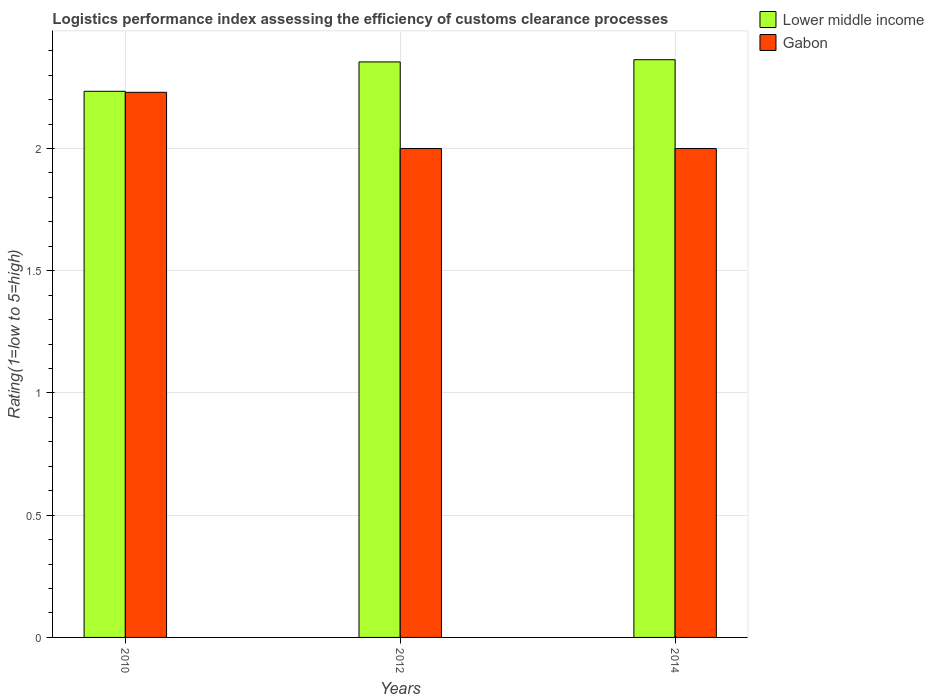How many different coloured bars are there?
Your response must be concise. 2. Are the number of bars per tick equal to the number of legend labels?
Offer a terse response. Yes. What is the Logistic performance index in Lower middle income in 2012?
Your answer should be compact. 2.35. Across all years, what is the maximum Logistic performance index in Gabon?
Ensure brevity in your answer.  2.23. Across all years, what is the minimum Logistic performance index in Lower middle income?
Your answer should be compact. 2.23. What is the total Logistic performance index in Gabon in the graph?
Provide a succinct answer. 6.23. What is the difference between the Logistic performance index in Gabon in 2010 and that in 2012?
Make the answer very short. 0.23. What is the difference between the Logistic performance index in Gabon in 2014 and the Logistic performance index in Lower middle income in 2012?
Your answer should be very brief. -0.35. What is the average Logistic performance index in Gabon per year?
Keep it short and to the point. 2.08. In the year 2014, what is the difference between the Logistic performance index in Gabon and Logistic performance index in Lower middle income?
Provide a short and direct response. -0.36. In how many years, is the Logistic performance index in Lower middle income greater than 0.8?
Offer a terse response. 3. What is the ratio of the Logistic performance index in Lower middle income in 2010 to that in 2012?
Provide a short and direct response. 0.95. Is the Logistic performance index in Lower middle income in 2010 less than that in 2012?
Offer a very short reply. Yes. Is the difference between the Logistic performance index in Gabon in 2010 and 2014 greater than the difference between the Logistic performance index in Lower middle income in 2010 and 2014?
Offer a very short reply. Yes. What is the difference between the highest and the second highest Logistic performance index in Lower middle income?
Ensure brevity in your answer.  0.01. What is the difference between the highest and the lowest Logistic performance index in Lower middle income?
Your response must be concise. 0.13. What does the 1st bar from the left in 2014 represents?
Keep it short and to the point. Lower middle income. What does the 2nd bar from the right in 2014 represents?
Provide a succinct answer. Lower middle income. Are all the bars in the graph horizontal?
Provide a succinct answer. No. How many years are there in the graph?
Your response must be concise. 3. Does the graph contain any zero values?
Offer a very short reply. No. Does the graph contain grids?
Provide a short and direct response. Yes. What is the title of the graph?
Make the answer very short. Logistics performance index assessing the efficiency of customs clearance processes. What is the label or title of the Y-axis?
Give a very brief answer. Rating(1=low to 5=high). What is the Rating(1=low to 5=high) in Lower middle income in 2010?
Your answer should be compact. 2.23. What is the Rating(1=low to 5=high) of Gabon in 2010?
Offer a very short reply. 2.23. What is the Rating(1=low to 5=high) in Lower middle income in 2012?
Give a very brief answer. 2.35. What is the Rating(1=low to 5=high) in Lower middle income in 2014?
Provide a short and direct response. 2.36. What is the Rating(1=low to 5=high) in Gabon in 2014?
Your response must be concise. 2. Across all years, what is the maximum Rating(1=low to 5=high) in Lower middle income?
Keep it short and to the point. 2.36. Across all years, what is the maximum Rating(1=low to 5=high) in Gabon?
Keep it short and to the point. 2.23. Across all years, what is the minimum Rating(1=low to 5=high) in Lower middle income?
Keep it short and to the point. 2.23. What is the total Rating(1=low to 5=high) in Lower middle income in the graph?
Provide a short and direct response. 6.95. What is the total Rating(1=low to 5=high) in Gabon in the graph?
Offer a very short reply. 6.23. What is the difference between the Rating(1=low to 5=high) of Lower middle income in 2010 and that in 2012?
Make the answer very short. -0.12. What is the difference between the Rating(1=low to 5=high) in Gabon in 2010 and that in 2012?
Your response must be concise. 0.23. What is the difference between the Rating(1=low to 5=high) in Lower middle income in 2010 and that in 2014?
Your answer should be very brief. -0.13. What is the difference between the Rating(1=low to 5=high) of Gabon in 2010 and that in 2014?
Give a very brief answer. 0.23. What is the difference between the Rating(1=low to 5=high) of Lower middle income in 2012 and that in 2014?
Provide a succinct answer. -0.01. What is the difference between the Rating(1=low to 5=high) in Lower middle income in 2010 and the Rating(1=low to 5=high) in Gabon in 2012?
Provide a succinct answer. 0.23. What is the difference between the Rating(1=low to 5=high) in Lower middle income in 2010 and the Rating(1=low to 5=high) in Gabon in 2014?
Your answer should be compact. 0.23. What is the difference between the Rating(1=low to 5=high) of Lower middle income in 2012 and the Rating(1=low to 5=high) of Gabon in 2014?
Your answer should be compact. 0.35. What is the average Rating(1=low to 5=high) of Lower middle income per year?
Offer a terse response. 2.32. What is the average Rating(1=low to 5=high) in Gabon per year?
Your response must be concise. 2.08. In the year 2010, what is the difference between the Rating(1=low to 5=high) in Lower middle income and Rating(1=low to 5=high) in Gabon?
Your response must be concise. 0. In the year 2012, what is the difference between the Rating(1=low to 5=high) of Lower middle income and Rating(1=low to 5=high) of Gabon?
Your response must be concise. 0.35. In the year 2014, what is the difference between the Rating(1=low to 5=high) in Lower middle income and Rating(1=low to 5=high) in Gabon?
Offer a very short reply. 0.36. What is the ratio of the Rating(1=low to 5=high) in Lower middle income in 2010 to that in 2012?
Offer a very short reply. 0.95. What is the ratio of the Rating(1=low to 5=high) in Gabon in 2010 to that in 2012?
Ensure brevity in your answer.  1.11. What is the ratio of the Rating(1=low to 5=high) in Lower middle income in 2010 to that in 2014?
Your answer should be very brief. 0.95. What is the ratio of the Rating(1=low to 5=high) in Gabon in 2010 to that in 2014?
Give a very brief answer. 1.11. What is the ratio of the Rating(1=low to 5=high) of Lower middle income in 2012 to that in 2014?
Provide a short and direct response. 1. What is the ratio of the Rating(1=low to 5=high) in Gabon in 2012 to that in 2014?
Offer a terse response. 1. What is the difference between the highest and the second highest Rating(1=low to 5=high) of Lower middle income?
Offer a very short reply. 0.01. What is the difference between the highest and the second highest Rating(1=low to 5=high) in Gabon?
Offer a terse response. 0.23. What is the difference between the highest and the lowest Rating(1=low to 5=high) of Lower middle income?
Your response must be concise. 0.13. What is the difference between the highest and the lowest Rating(1=low to 5=high) of Gabon?
Your answer should be very brief. 0.23. 